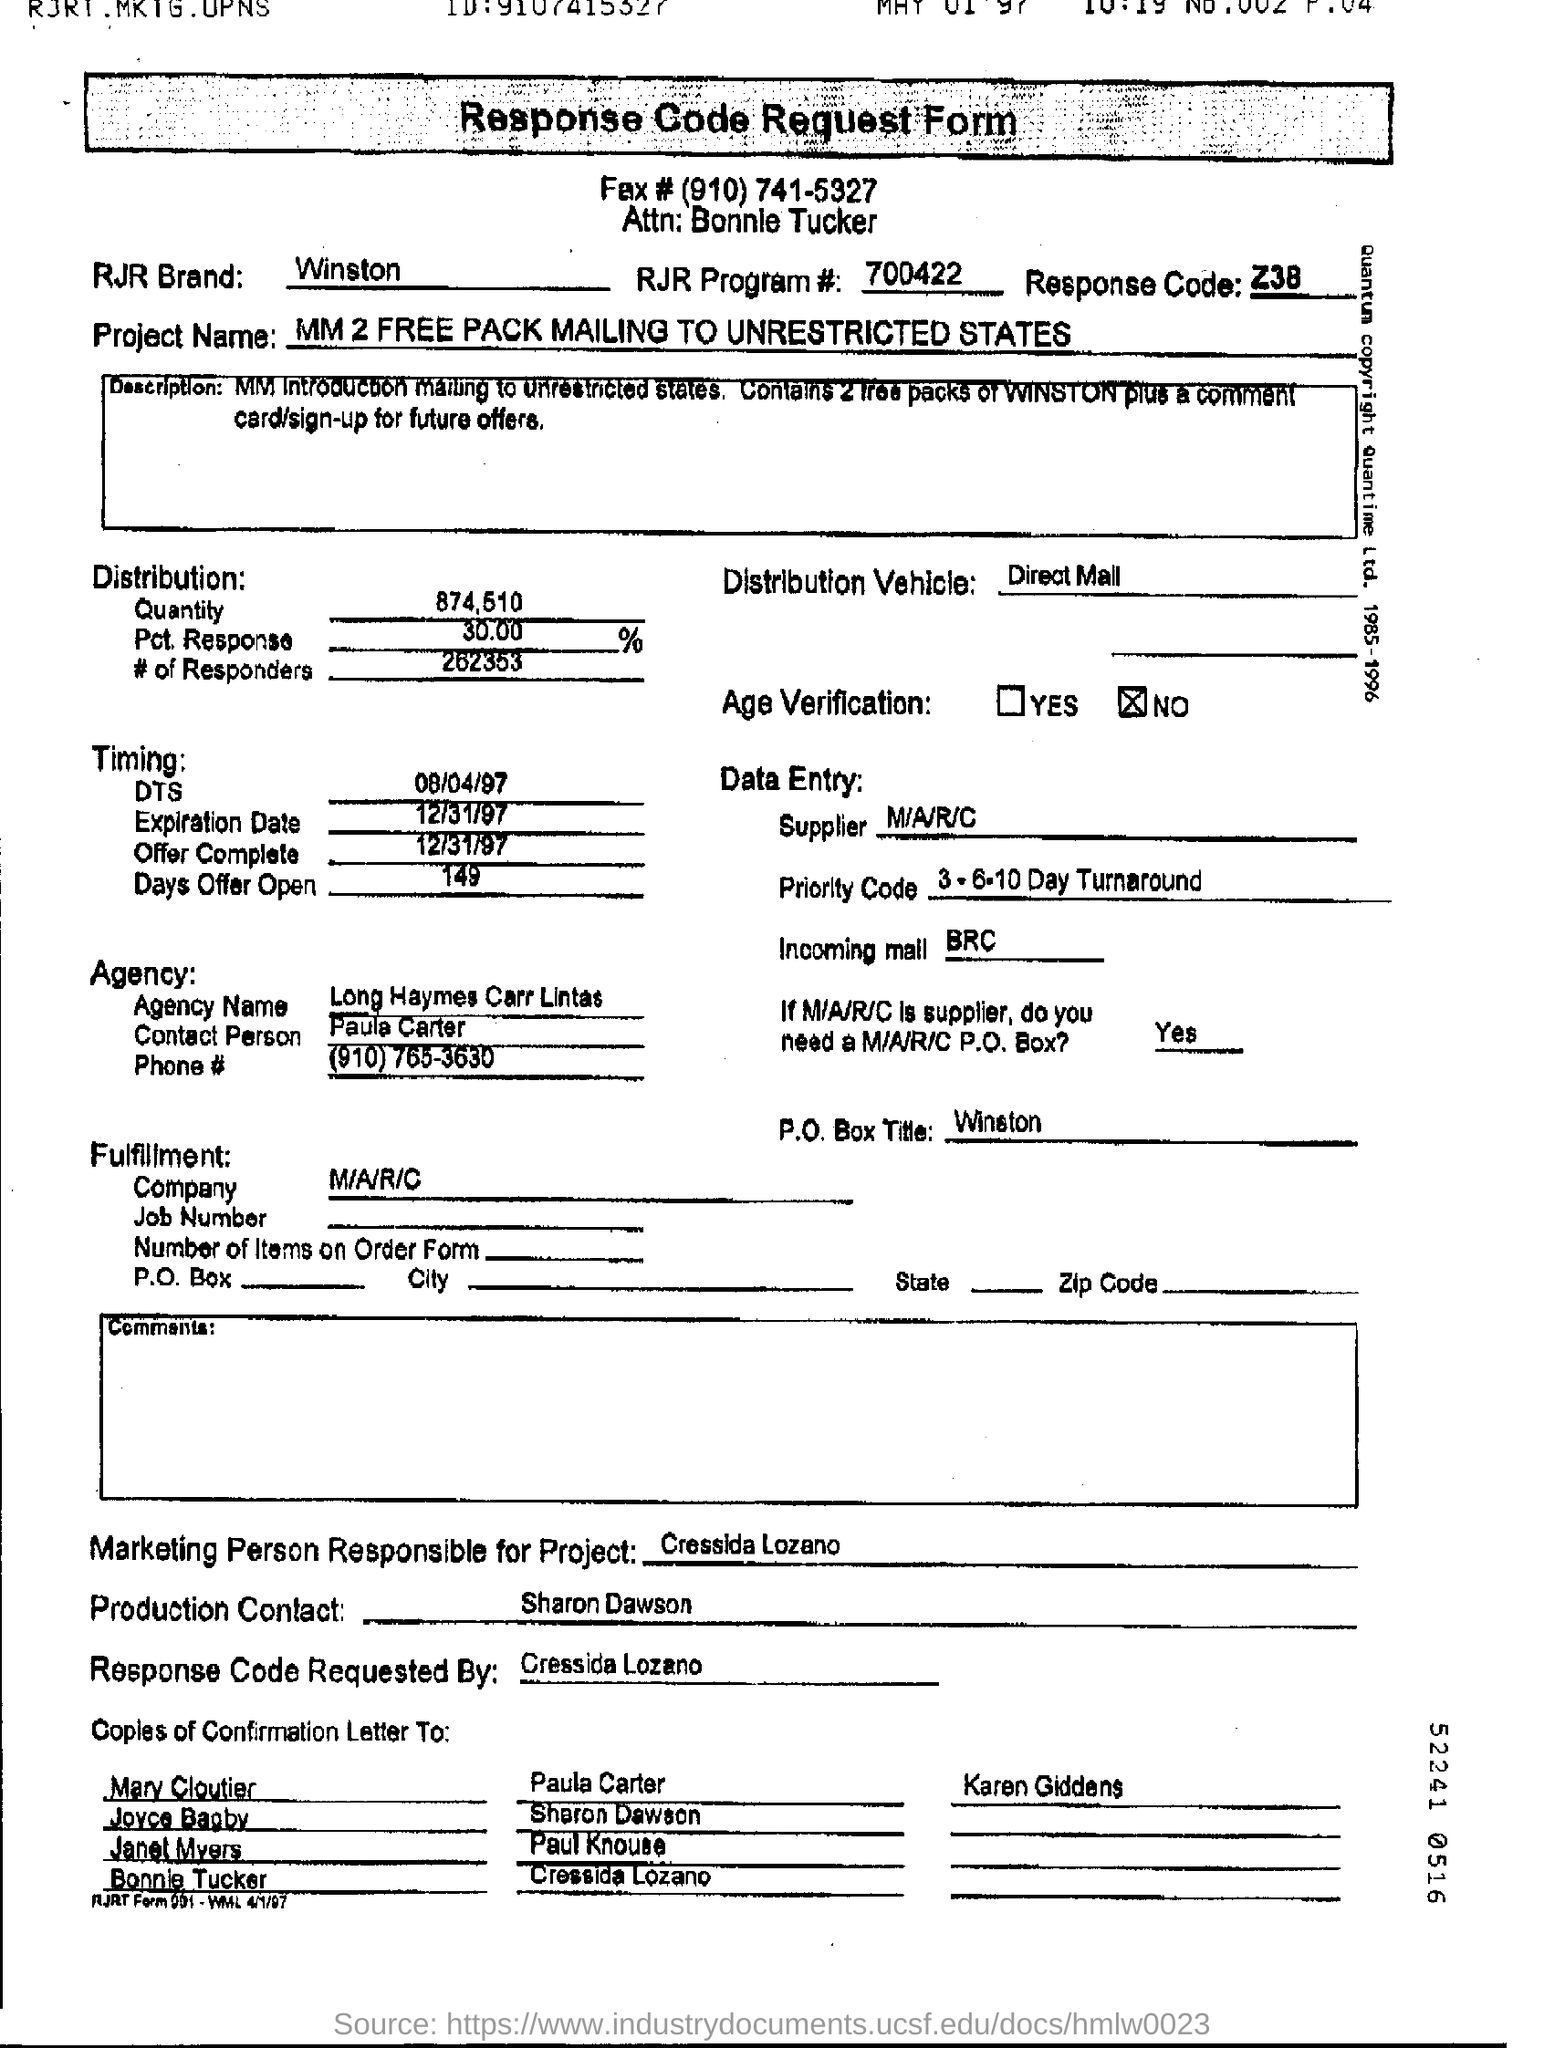What is the distribution quantity?
Keep it short and to the point. 874.510. By whom response code was requested?
Provide a short and direct response. Cressida Lozano. What is RJR Brand?
Offer a very short reply. Winston. What is the response code?
Give a very brief answer. Z38. 